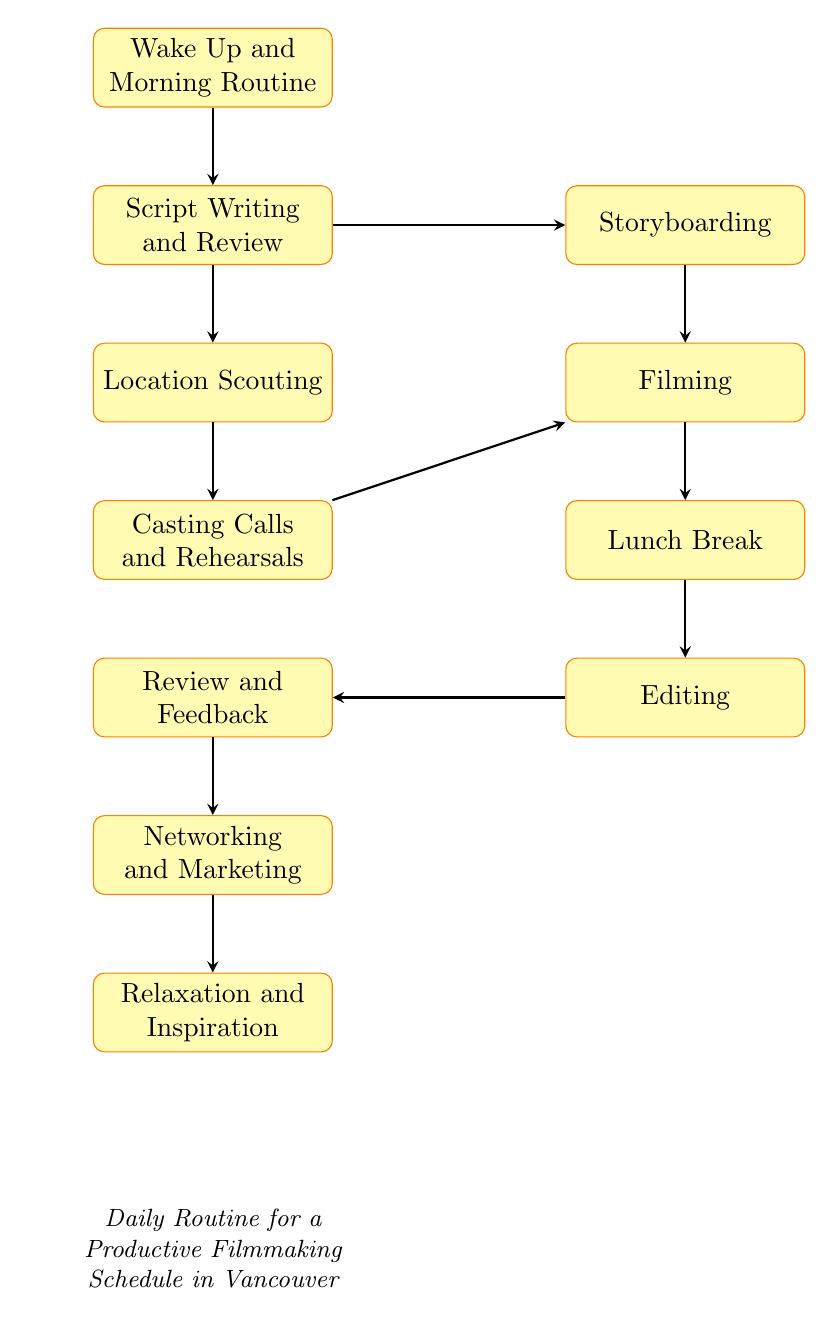What is the first step in the daily routine? The first step is indicated as "Wake Up and Morning Routine." By observing the diagram, it's clear that "Wake Up and Morning Routine" is at the top, representing the starting point of the daily routine.
Answer: Wake Up and Morning Routine How many main activities are depicted in this flow chart? By counting the process nodes in the diagram, we find that there are 10 main activities listed. Each node represents an activity that contributes to the productive filmmaking schedule.
Answer: 10 What is the activity that follows "Lunch Break"? Looking at the flow, after "Lunch Break," the next activity is "Editing," which is linked directly beneath "Lunch Break" in the sequence of the routine.
Answer: Editing Which two activities precede "Filming"? The diagram shows that both "Casting Calls and Rehearsals" and "Storyboarding" lead into "Filming." Each of those activities is positioned directly above "Filming," indicating they come before it in the routine.
Answer: Casting Calls and Rehearsals, Storyboarding What is the purpose of "Review and Feedback"? In the context of the diagram, "Review and Feedback" serves as time allocated for assessing the day's progress and gathering insights. Following "Editing," it allows filmmakers to reflect on and improve their work.
Answer: Review the day's work and gather feedback What activity is linked to "Script Writing and Review"? "Script Writing and Review" is connected to "Storyboarding," focusing on the pre-production aspects of filmmaking. This connection illustrates the importance of conceptual development before moving on to later stages.
Answer: Storyboarding Which activity flows directly into "Networking and Marketing"? The diagram indicates that "Review and Feedback" is the direct predecessor of "Networking and Marketing," showing that networking activities come after the review stage.
Answer: Review and Feedback Which activity concludes the daily routine? By analyzing the layout of the flow chart, it's evident that "Relaxation and Inspiration" is the last activity, visually positioned at the bottom of the diagram.
Answer: Relaxation and Inspiration What is the relationship between "Script Writing and Review" and "Location Scouting"? The diagram shows a direct downward flow from "Script Writing and Review" to "Location Scouting," indicating that they are sequentially linked activities within the routine. This means that script preparation directly influences the scouting efforts after.
Answer: Sequentially linked activities 